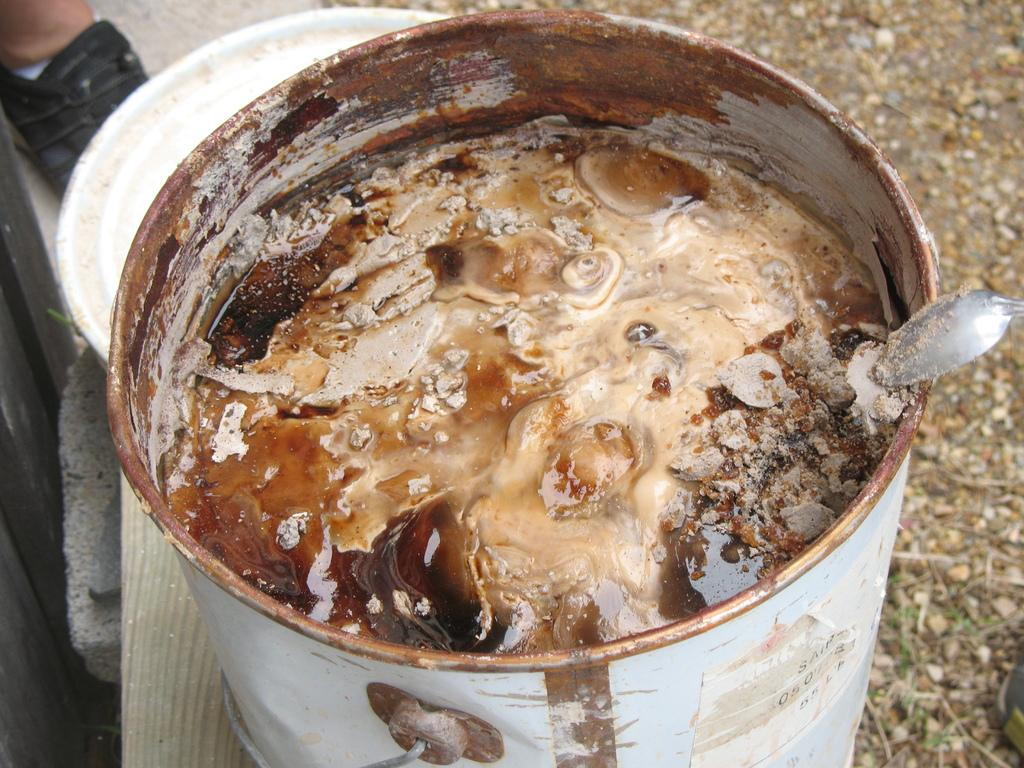What is located in the foreground of the image? There is a bowl in the foreground of the image. What is inside the bowl? There is a cream-like substance in the bowl. What other object can be seen in the image? A vessel is present in the image. Where is the spoon located in the image? The spoon is in the background of the image. Can you describe the person's leg visible in the background? A person's leg is visible in the background of the image. What can be inferred about the time of day when the image was taken? The image was likely taken during the day, as there is sufficient light to see the objects clearly. What organization is responsible for the steam coming out of the bowl in the image? There is no steam coming out of the bowl in the image, and therefore no organization is responsible for it. 